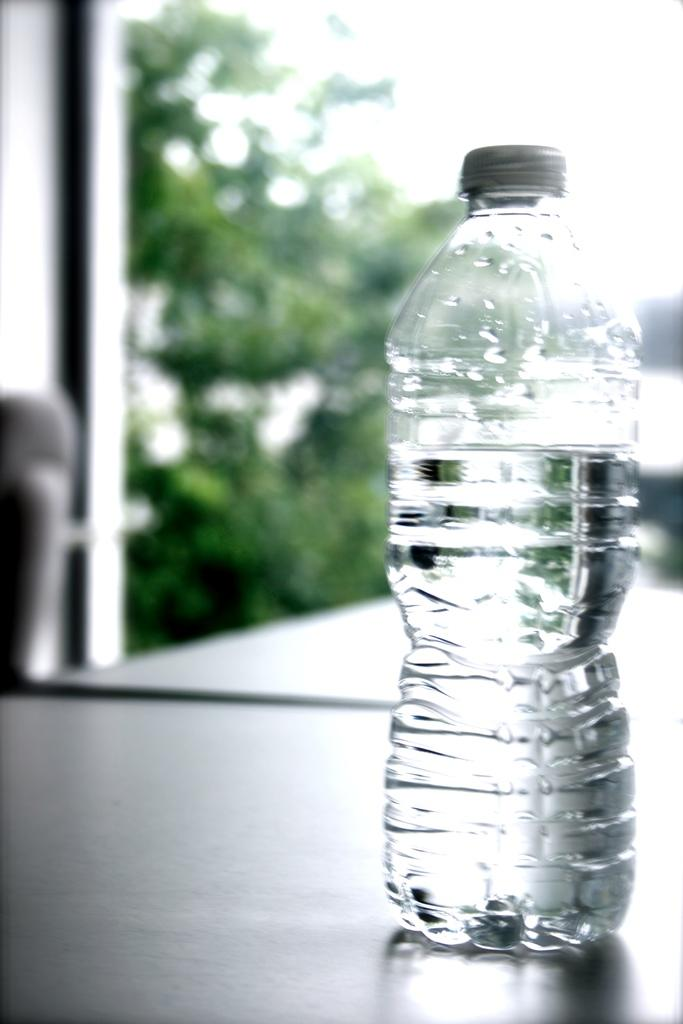What object is present in the image that is filled with liquid? There is a bottle in the image that is filled with liquid. What can be seen in the background of the image? There are trees in the background of the image. What type of bird is participating in the competition in the image? There is no bird or competition present in the image. What is the butter used for in the image? There is no butter present in the image. 